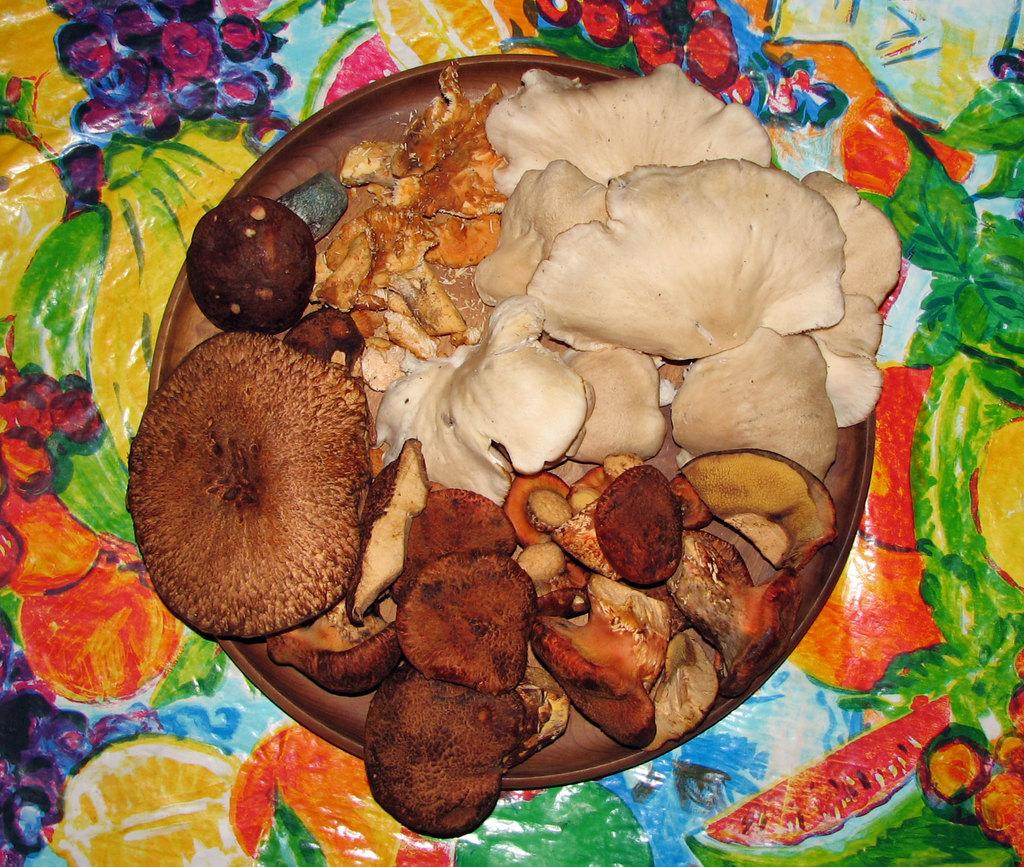What is on the plate that is visible in the image? The plate contains mushrooms and other eatables. Where is the plate located in the image? The plate is placed on a table. What is covering the table in the image? The table is covered with a colorful sheet. What type of tin can be seen turning on the table in the image? There is no tin present in the image, and nothing is turning on the table. 